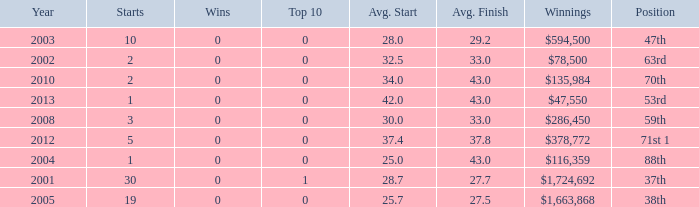What is the mean top 10 score for 2 starts, earnings of $135,984 and an average finish above 43? None. 